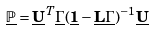Convert formula to latex. <formula><loc_0><loc_0><loc_500><loc_500>\underline { \mathbb { P } } = \underline { \mathbf U } ^ { T } \underline { \mathbf \Gamma } ( \underline { \mathbf 1 } - \underline { \mathbf L } \underline { \mathbf \Gamma } ) ^ { - 1 } \underline { \mathbf U }</formula> 